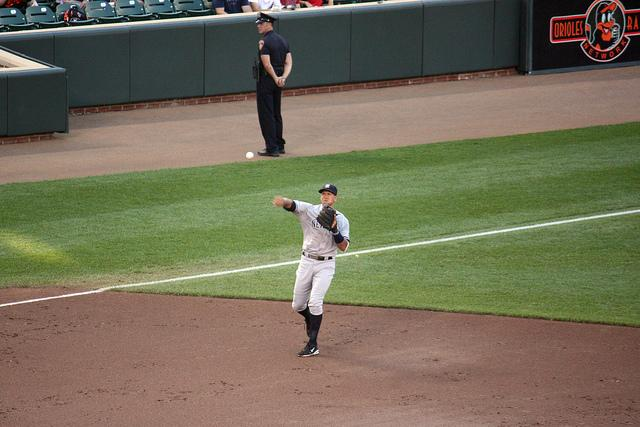What profession is the man facing the crowd? police 